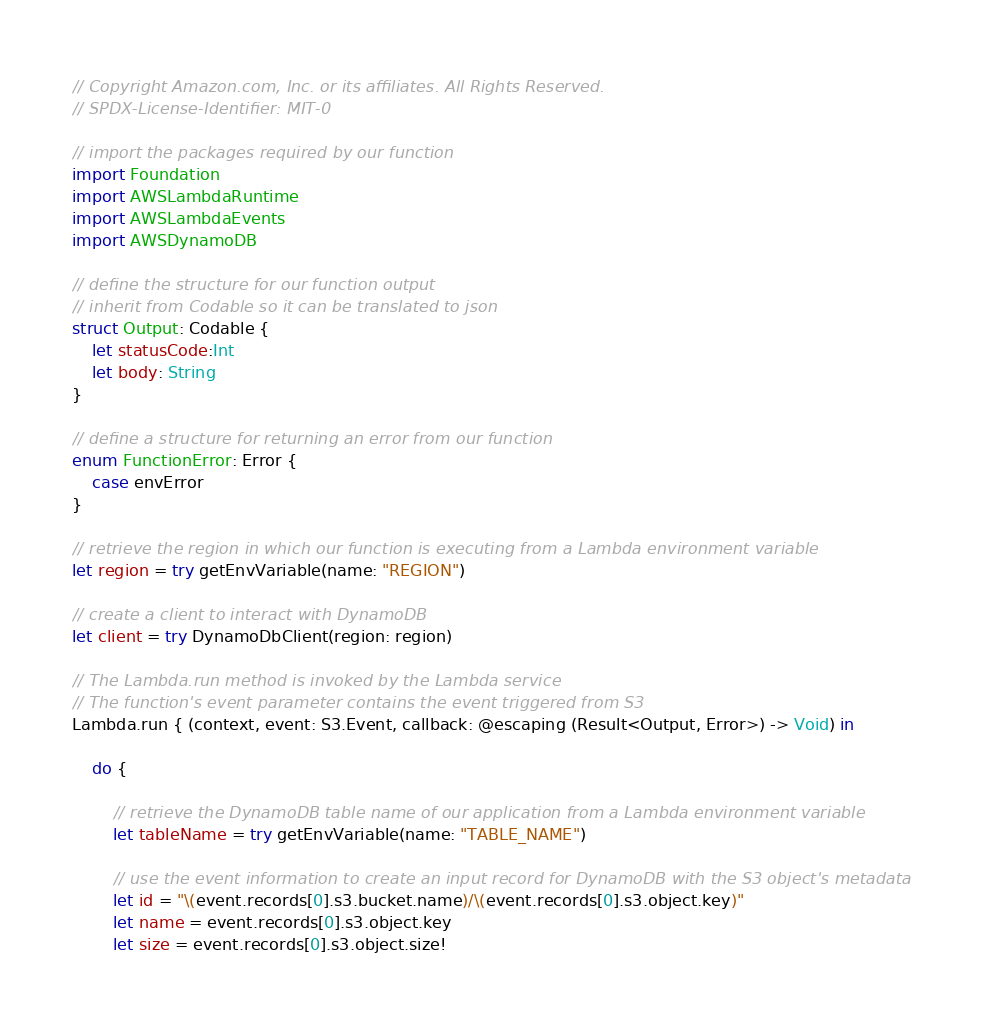Convert code to text. <code><loc_0><loc_0><loc_500><loc_500><_Swift_>// Copyright Amazon.com, Inc. or its affiliates. All Rights Reserved.
// SPDX-License-Identifier: MIT-0

// import the packages required by our function
import Foundation
import AWSLambdaRuntime
import AWSLambdaEvents
import AWSDynamoDB

// define the structure for our function output
// inherit from Codable so it can be translated to json
struct Output: Codable {
    let statusCode:Int
    let body: String
}

// define a structure for returning an error from our function
enum FunctionError: Error {
    case envError
}

// retrieve the region in which our function is executing from a Lambda environment variable
let region = try getEnvVariable(name: "REGION")

// create a client to interact with DynamoDB
let client = try DynamoDbClient(region: region)

// The Lambda.run method is invoked by the Lambda service
// The function's event parameter contains the event triggered from S3
Lambda.run { (context, event: S3.Event, callback: @escaping (Result<Output, Error>) -> Void) in
  
    do {

        // retrieve the DynamoDB table name of our application from a Lambda environment variable
        let tableName = try getEnvVariable(name: "TABLE_NAME")
        
        // use the event information to create an input record for DynamoDB with the S3 object's metadata
        let id = "\(event.records[0].s3.bucket.name)/\(event.records[0].s3.object.key)"
        let name = event.records[0].s3.object.key
        let size = event.records[0].s3.object.size!
</code> 